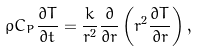Convert formula to latex. <formula><loc_0><loc_0><loc_500><loc_500>\rho C _ { P } \frac { \partial T } { \partial t } = \frac { k } { r ^ { 2 } } \frac { \partial } { \partial r } \left ( r ^ { 2 } \frac { \partial T } { \partial r } \right ) ,</formula> 